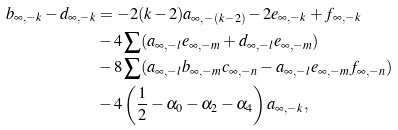<formula> <loc_0><loc_0><loc_500><loc_500>b _ { \infty , - k } - d _ { \infty , - k } & = - 2 ( k - 2 ) a _ { \infty , - ( k - 2 ) } - 2 e _ { \infty , - k } + f _ { \infty , - k } \\ & - 4 \sum ( a _ { \infty , - l } e _ { \infty , - m } + d _ { \infty , - l } e _ { \infty , - m } ) \\ & - 8 \sum ( a _ { \infty , - l } b _ { \infty , - m } c _ { \infty , - n } - a _ { \infty , - l } e _ { \infty , - m } f _ { \infty , - n } ) \\ & - 4 \left ( \frac { 1 } { 2 } - \alpha _ { 0 } - \alpha _ { 2 } - \alpha _ { 4 } \right ) a _ { \infty , - k } ,</formula> 